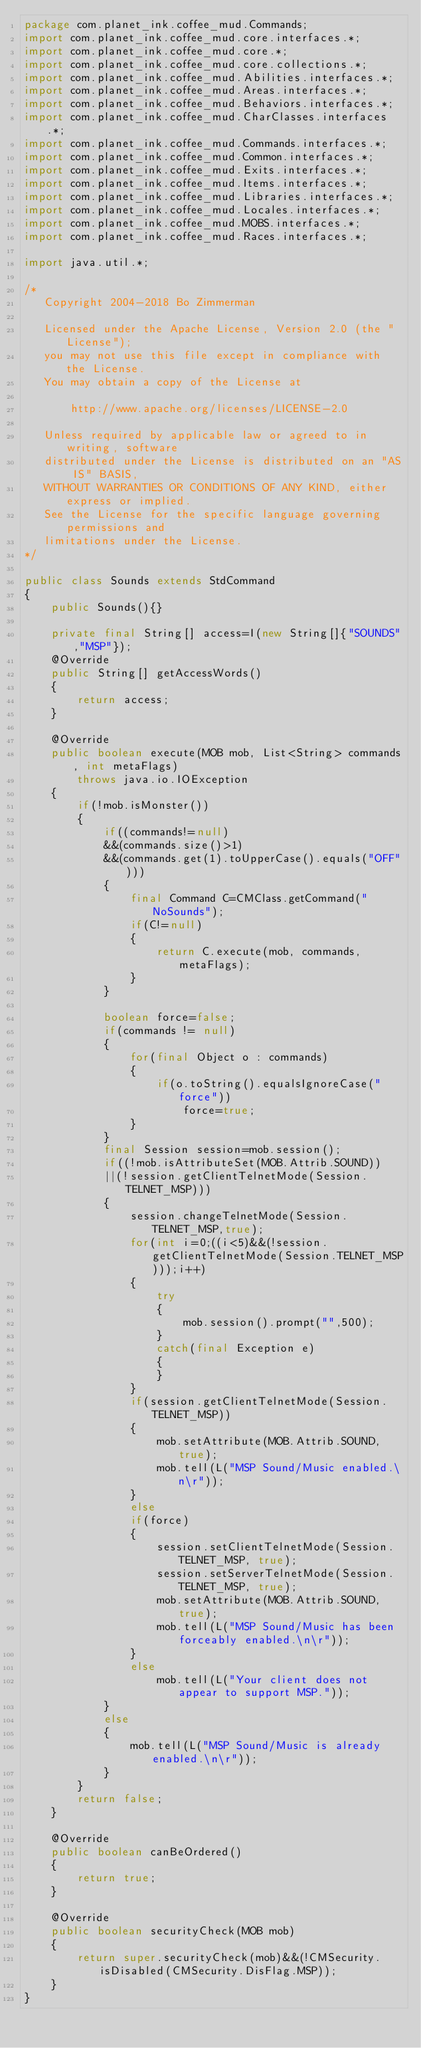<code> <loc_0><loc_0><loc_500><loc_500><_Java_>package com.planet_ink.coffee_mud.Commands;
import com.planet_ink.coffee_mud.core.interfaces.*;
import com.planet_ink.coffee_mud.core.*;
import com.planet_ink.coffee_mud.core.collections.*;
import com.planet_ink.coffee_mud.Abilities.interfaces.*;
import com.planet_ink.coffee_mud.Areas.interfaces.*;
import com.planet_ink.coffee_mud.Behaviors.interfaces.*;
import com.planet_ink.coffee_mud.CharClasses.interfaces.*;
import com.planet_ink.coffee_mud.Commands.interfaces.*;
import com.planet_ink.coffee_mud.Common.interfaces.*;
import com.planet_ink.coffee_mud.Exits.interfaces.*;
import com.planet_ink.coffee_mud.Items.interfaces.*;
import com.planet_ink.coffee_mud.Libraries.interfaces.*;
import com.planet_ink.coffee_mud.Locales.interfaces.*;
import com.planet_ink.coffee_mud.MOBS.interfaces.*;
import com.planet_ink.coffee_mud.Races.interfaces.*;

import java.util.*;

/*
   Copyright 2004-2018 Bo Zimmerman

   Licensed under the Apache License, Version 2.0 (the "License");
   you may not use this file except in compliance with the License.
   You may obtain a copy of the License at

	   http://www.apache.org/licenses/LICENSE-2.0

   Unless required by applicable law or agreed to in writing, software
   distributed under the License is distributed on an "AS IS" BASIS,
   WITHOUT WARRANTIES OR CONDITIONS OF ANY KIND, either express or implied.
   See the License for the specific language governing permissions and
   limitations under the License.
*/

public class Sounds extends StdCommand
{
	public Sounds(){}

	private final String[] access=I(new String[]{"SOUNDS","MSP"});
	@Override
	public String[] getAccessWords()
	{
		return access;
	}

	@Override
	public boolean execute(MOB mob, List<String> commands, int metaFlags)
		throws java.io.IOException
	{
		if(!mob.isMonster())
		{
			if((commands!=null)
			&&(commands.size()>1)
			&&(commands.get(1).toUpperCase().equals("OFF")))
			{
				final Command C=CMClass.getCommand("NoSounds");
				if(C!=null)
				{
					return C.execute(mob, commands, metaFlags);
				}
			}
			
			boolean force=false;
			if(commands != null)
			{
				for(final Object o : commands)
				{
					if(o.toString().equalsIgnoreCase("force"))
						force=true;
				}
			}
			final Session session=mob.session();
			if((!mob.isAttributeSet(MOB.Attrib.SOUND))
			||(!session.getClientTelnetMode(Session.TELNET_MSP)))
			{
				session.changeTelnetMode(Session.TELNET_MSP,true);
				for(int i=0;((i<5)&&(!session.getClientTelnetMode(Session.TELNET_MSP)));i++)
				{
					try
					{
						mob.session().prompt("",500);
					}
					catch(final Exception e)
					{
					}
				}
				if(session.getClientTelnetMode(Session.TELNET_MSP))
				{
					mob.setAttribute(MOB.Attrib.SOUND,true);
					mob.tell(L("MSP Sound/Music enabled.\n\r"));
				}
				else
				if(force)
				{
					session.setClientTelnetMode(Session.TELNET_MSP, true);
					session.setServerTelnetMode(Session.TELNET_MSP, true);
					mob.setAttribute(MOB.Attrib.SOUND,true);
					mob.tell(L("MSP Sound/Music has been forceably enabled.\n\r"));
				}
				else
					mob.tell(L("Your client does not appear to support MSP."));
			}
			else
			{
				mob.tell(L("MSP Sound/Music is already enabled.\n\r"));
			}
		}
		return false;
	}

	@Override
	public boolean canBeOrdered()
	{
		return true;
	}

	@Override
	public boolean securityCheck(MOB mob)
	{
		return super.securityCheck(mob)&&(!CMSecurity.isDisabled(CMSecurity.DisFlag.MSP));
	}
}
</code> 